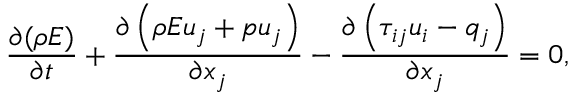Convert formula to latex. <formula><loc_0><loc_0><loc_500><loc_500>\frac { \partial ( \rho E ) } { \partial t } + \frac { \partial \left ( \rho E u _ { j } + p u _ { j } \right ) } { \partial x _ { j } } - \frac { \partial \left ( \tau _ { i j } u _ { i } - q _ { j } \right ) } { \partial x _ { j } } = 0 ,</formula> 